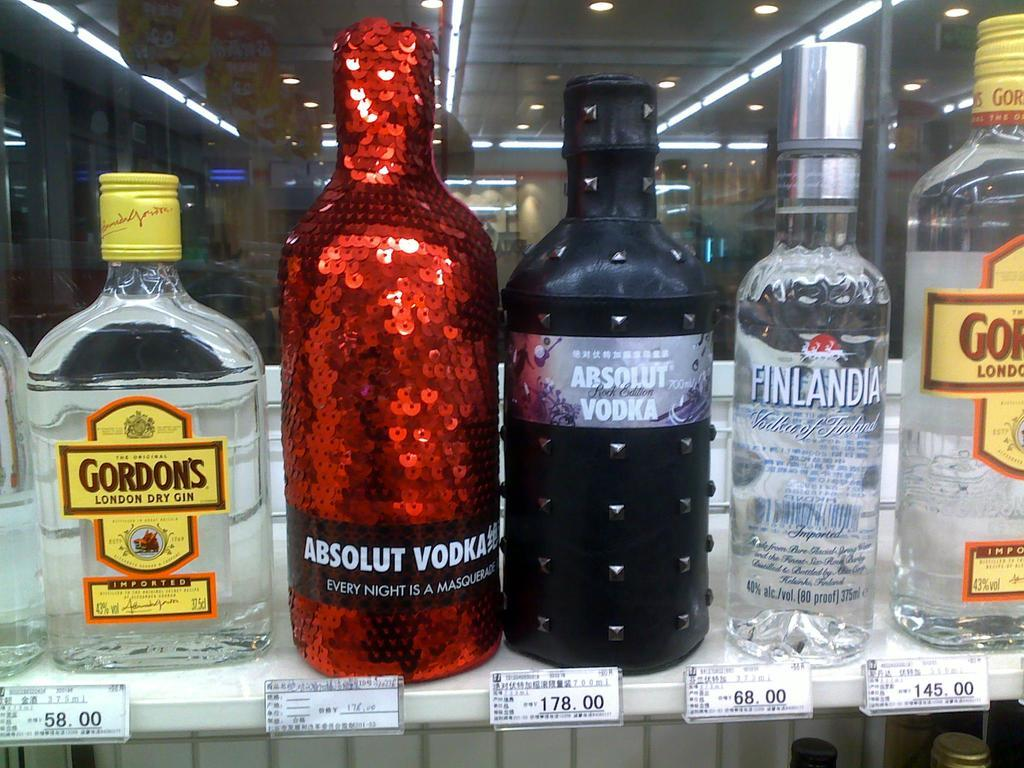<image>
Describe the image concisely. A shelf shows different kinds of Vodka with price labels underneath. 